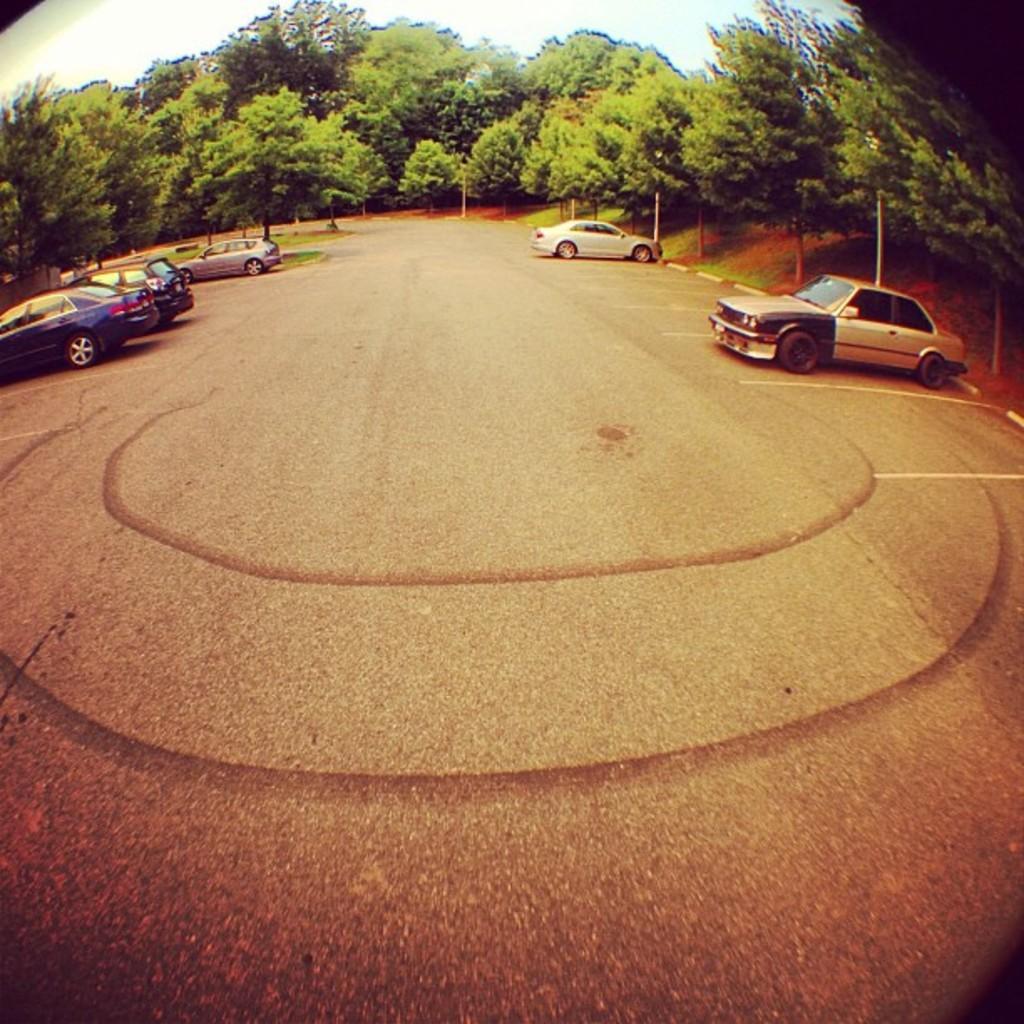How would you summarize this image in a sentence or two? This image consists of cars which are parked on the road. At the bottom, we can see a road. In the background, there are trees. At the top, there is sky. 